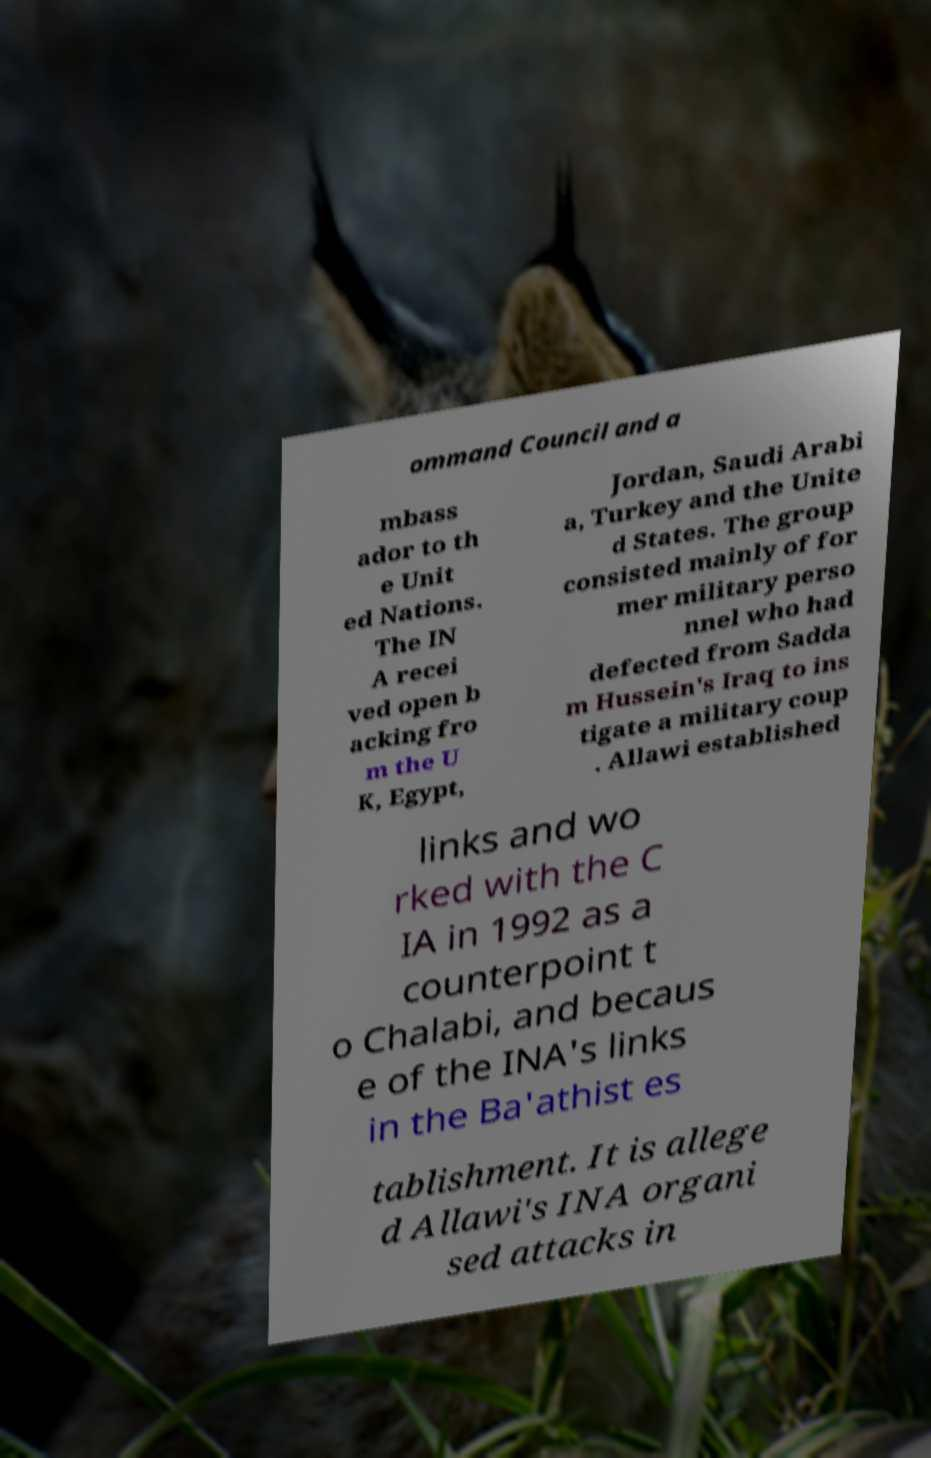Could you extract and type out the text from this image? ommand Council and a mbass ador to th e Unit ed Nations. The IN A recei ved open b acking fro m the U K, Egypt, Jordan, Saudi Arabi a, Turkey and the Unite d States. The group consisted mainly of for mer military perso nnel who had defected from Sadda m Hussein's Iraq to ins tigate a military coup . Allawi established links and wo rked with the C IA in 1992 as a counterpoint t o Chalabi, and becaus e of the INA's links in the Ba'athist es tablishment. It is allege d Allawi's INA organi sed attacks in 